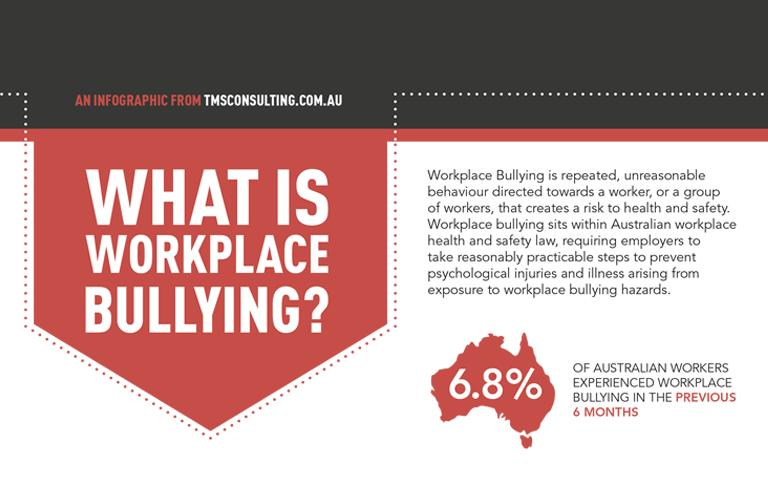Outline some significant characteristics in this image. Workplace bullying is a type of negative practice that is being discussed here. In the decimal digit shown, the color red or white? The answer is white. 